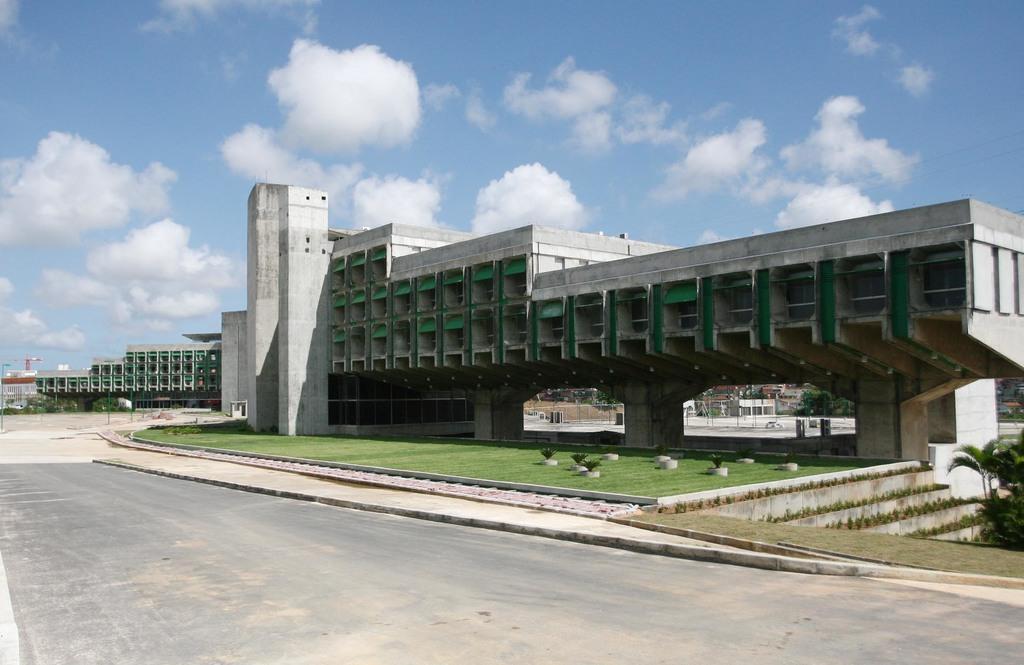Please provide a concise description of this image. In this picture we can see buildings, trees, grass, road and in the background we can see the sky with clouds. 